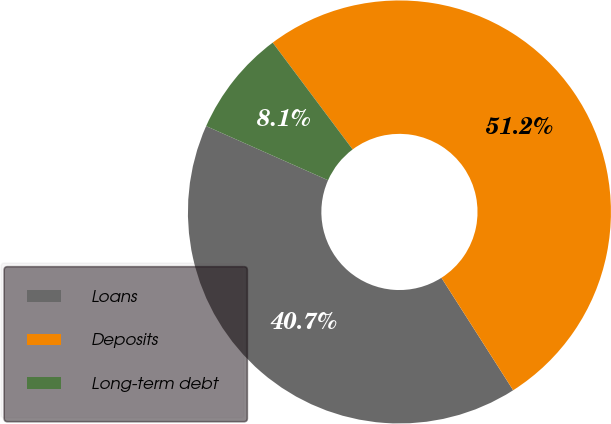Convert chart. <chart><loc_0><loc_0><loc_500><loc_500><pie_chart><fcel>Loans<fcel>Deposits<fcel>Long-term debt<nl><fcel>40.69%<fcel>51.19%<fcel>8.12%<nl></chart> 